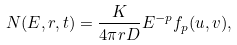Convert formula to latex. <formula><loc_0><loc_0><loc_500><loc_500>N ( E , r , t ) = \frac { K } { 4 \pi r D } E ^ { - p } f _ { p } ( u , v ) ,</formula> 